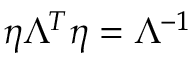<formula> <loc_0><loc_0><loc_500><loc_500>\eta \Lambda ^ { T } \eta = \Lambda ^ { - 1 }</formula> 